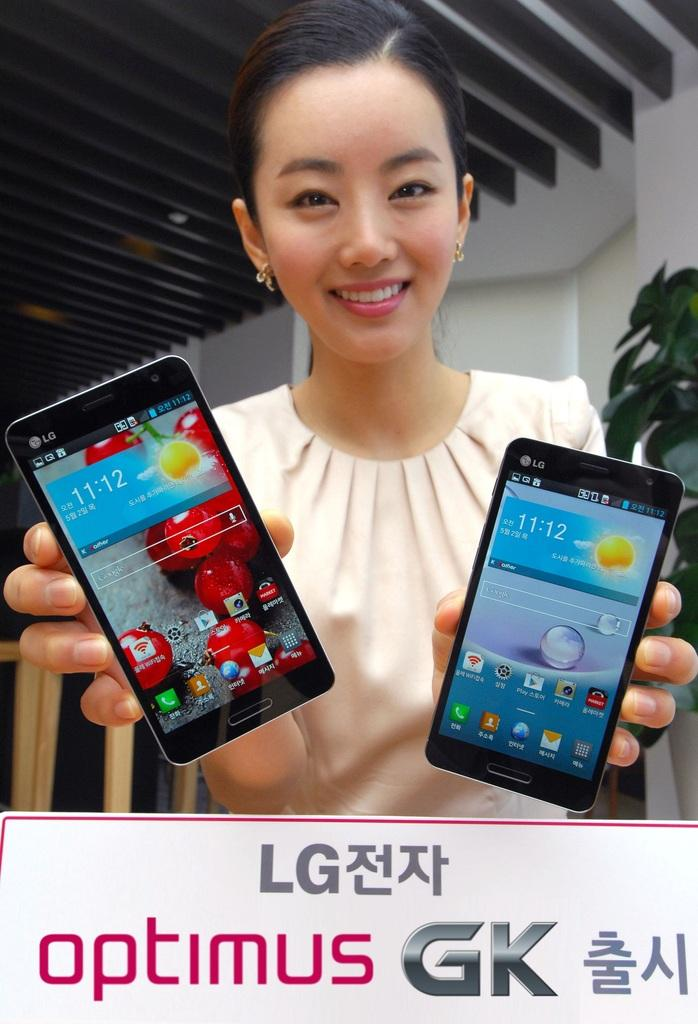Provide a one-sentence caption for the provided image. A smiling woman holds up two LG Optimus GK phones. 